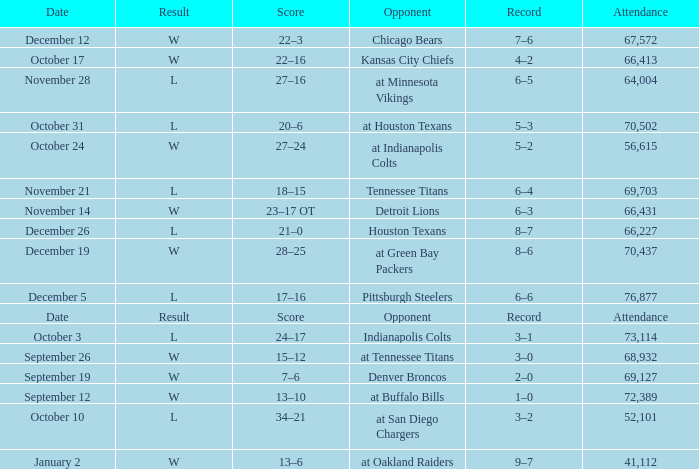What is the record with a "w" result, dated january 2? 9–7. 